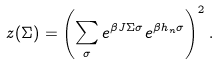<formula> <loc_0><loc_0><loc_500><loc_500>z ( \Sigma ) = \left ( \sum _ { \sigma } e ^ { \beta J \Sigma \sigma } e ^ { \beta h _ { n } \sigma } \right ) ^ { 2 } .</formula> 